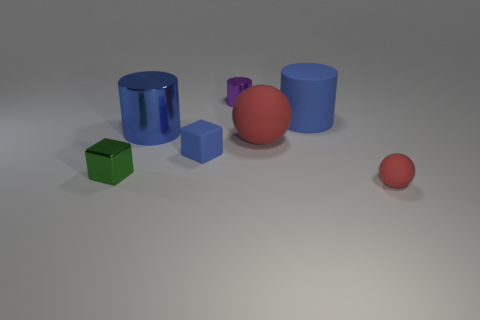Is the size of the purple metallic cylinder the same as the blue matte object behind the small blue object?
Your answer should be compact. No. What color is the large cylinder to the left of the blue cube that is on the right side of the tiny metal cube?
Give a very brief answer. Blue. How many other things are there of the same color as the tiny rubber sphere?
Your answer should be very brief. 1. How big is the blue metal object?
Your answer should be compact. Large. Are there more blue matte blocks that are right of the small rubber cube than large metal cylinders that are behind the purple metal cylinder?
Offer a terse response. No. There is a sphere that is behind the green cube; how many small blocks are on the right side of it?
Your answer should be very brief. 0. Is the shape of the big blue thing that is to the left of the large red thing the same as  the green thing?
Offer a terse response. No. There is another large object that is the same shape as the large shiny thing; what material is it?
Give a very brief answer. Rubber. How many green things are the same size as the matte block?
Provide a succinct answer. 1. There is a metal thing that is on the right side of the green cube and on the left side of the purple metallic cylinder; what color is it?
Keep it short and to the point. Blue. 